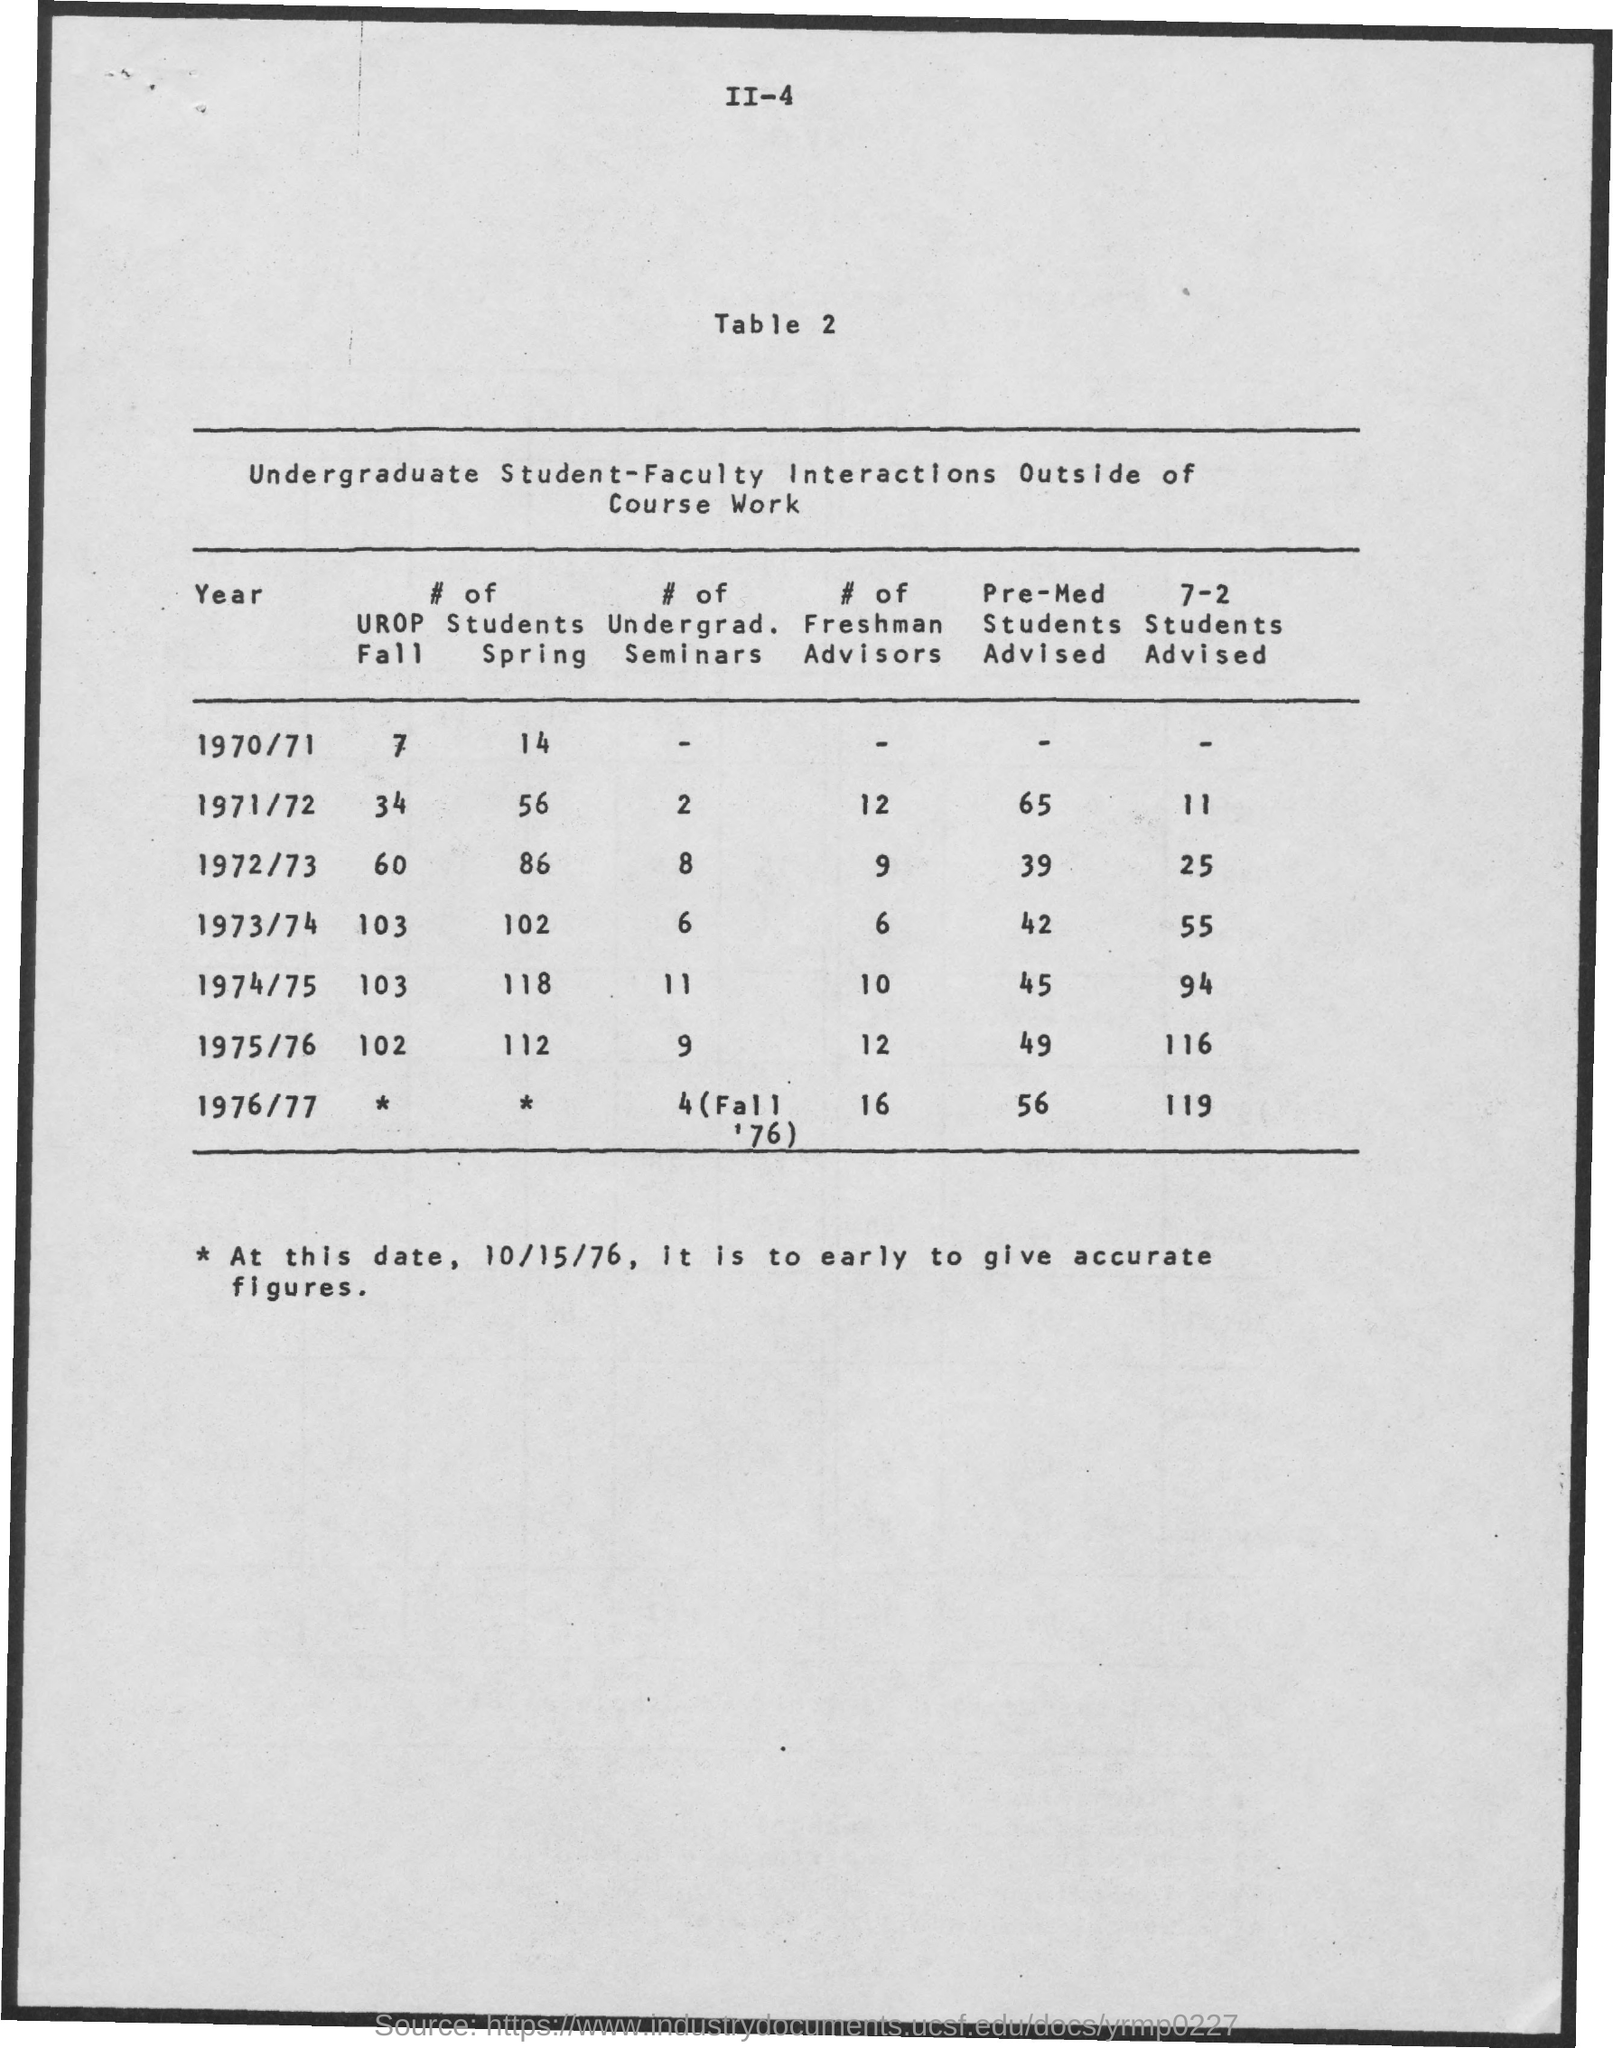Give some essential details in this illustration. In the year 1974/75, there were the most number of students during spring. The title of Table 2 is "What is the title of table 2? Undergraduate Student-Faculty Interactions Outside of Course Work.. 